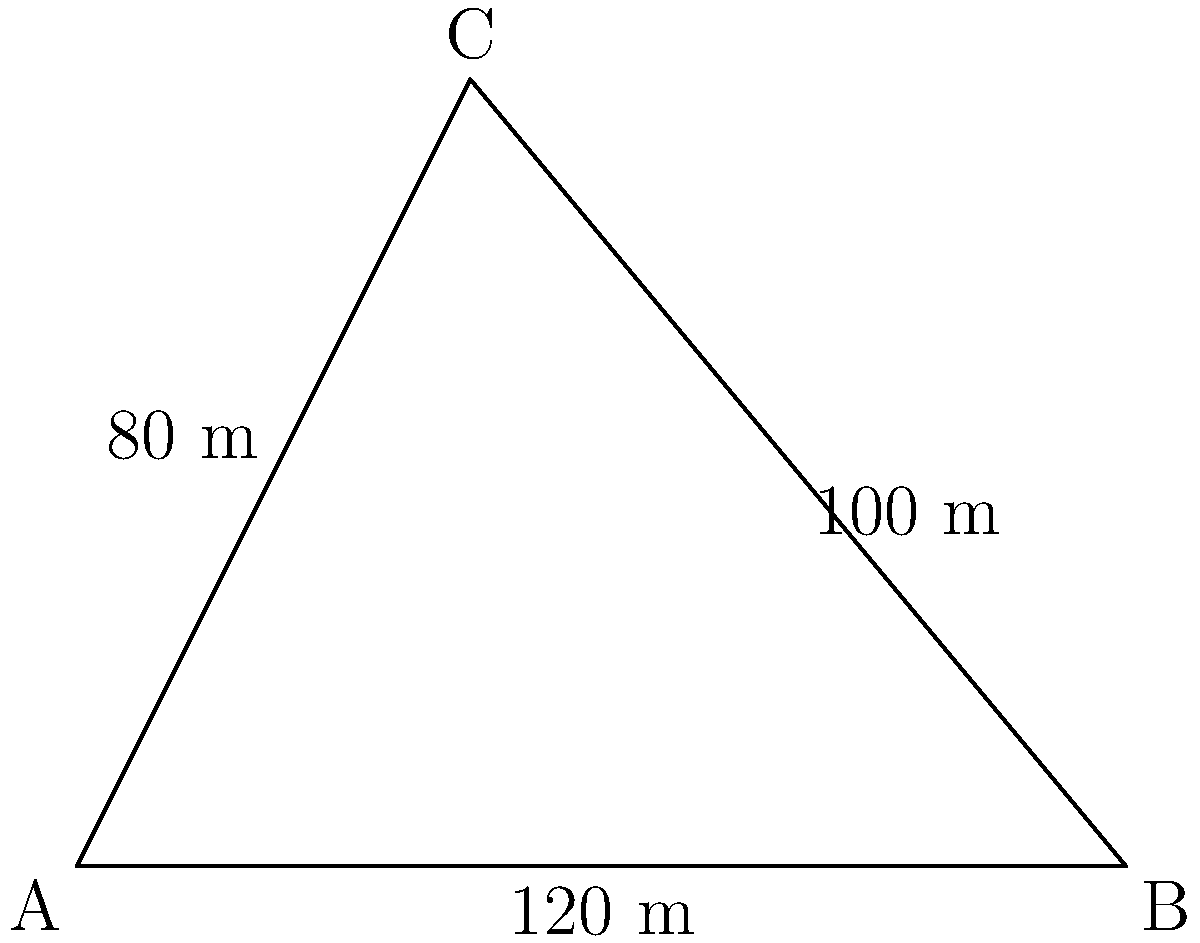In a legal dispute over property boundaries, you need to calculate the area of a triangular piece of land. The surveyor has provided the following measurements: side AB is 120 meters, side BC is 100 meters, and side AC is 80 meters. Using Heron's formula, what is the area of this triangular property in square meters? Round your answer to the nearest whole number. To solve this problem, we'll use Heron's formula for the area of a triangle given the lengths of its sides. Let's break it down step-by-step:

1) Heron's formula states that the area $A$ of a triangle with sides $a$, $b$, and $c$ is:

   $A = \sqrt{s(s-a)(s-b)(s-c)}$

   where $s$ is the semi-perimeter: $s = \frac{a + b + c}{2}$

2) In our case:
   $a = 120$ m
   $b = 100$ m
   $c = 80$ m

3) Calculate the semi-perimeter $s$:
   $s = \frac{120 + 100 + 80}{2} = \frac{300}{2} = 150$ m

4) Now, let's substitute these values into Heron's formula:

   $A = \sqrt{150(150-120)(150-100)(150-80)}$

5) Simplify:
   $A = \sqrt{150 \cdot 30 \cdot 50 \cdot 70}$

6) Multiply under the square root:
   $A = \sqrt{15,750,000}$

7) Calculate the square root:
   $A \approx 3,968.63$ m²

8) Rounding to the nearest whole number:
   $A \approx 3,969$ m²

This calculation provides the area of the triangular property, which is crucial for accurate property boundary descriptions in legal documentation.
Answer: 3,969 m² 